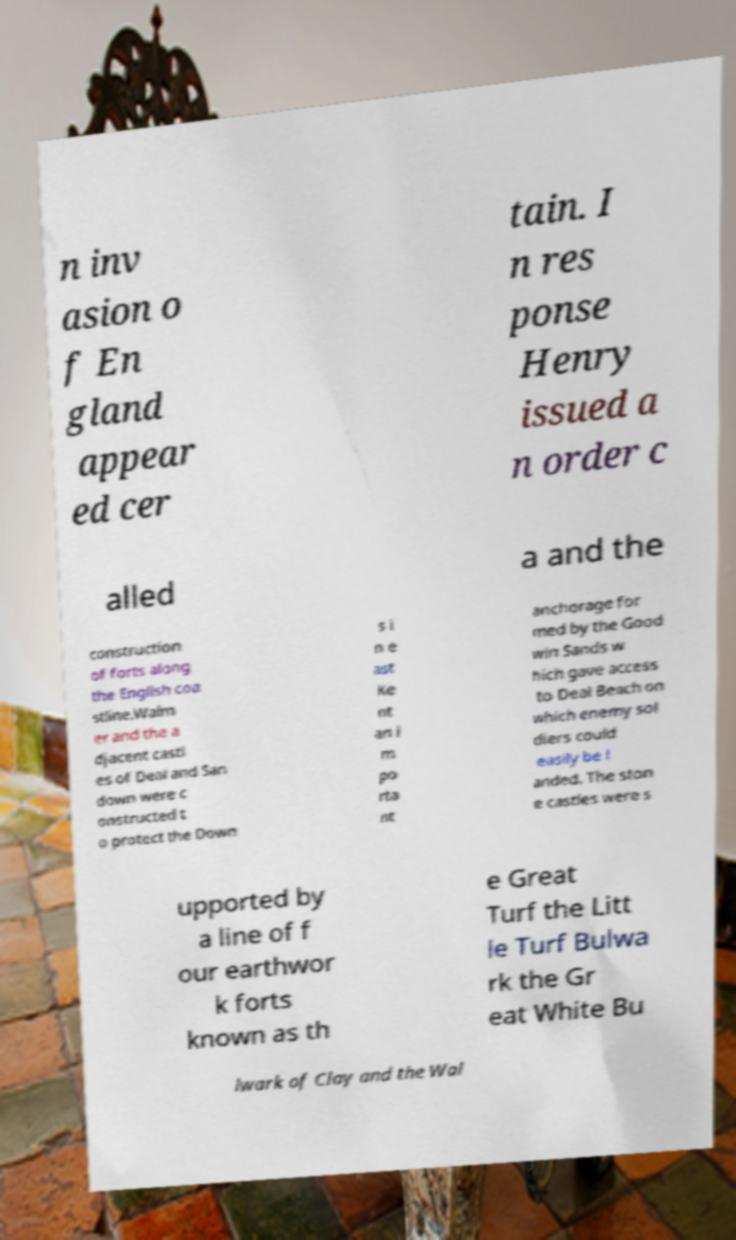Could you assist in decoding the text presented in this image and type it out clearly? n inv asion o f En gland appear ed cer tain. I n res ponse Henry issued a n order c alled a and the construction of forts along the English coa stline.Walm er and the a djacent castl es of Deal and San down were c onstructed t o protect the Down s i n e ast Ke nt an i m po rta nt anchorage for med by the Good win Sands w hich gave access to Deal Beach on which enemy sol diers could easily be l anded. The ston e castles were s upported by a line of f our earthwor k forts known as th e Great Turf the Litt le Turf Bulwa rk the Gr eat White Bu lwark of Clay and the Wal 